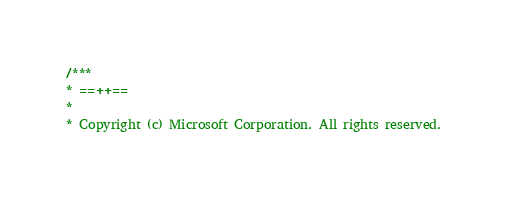<code> <loc_0><loc_0><loc_500><loc_500><_C++_>/***
* ==++==
*
* Copyright (c) Microsoft Corporation. All rights reserved.</code> 